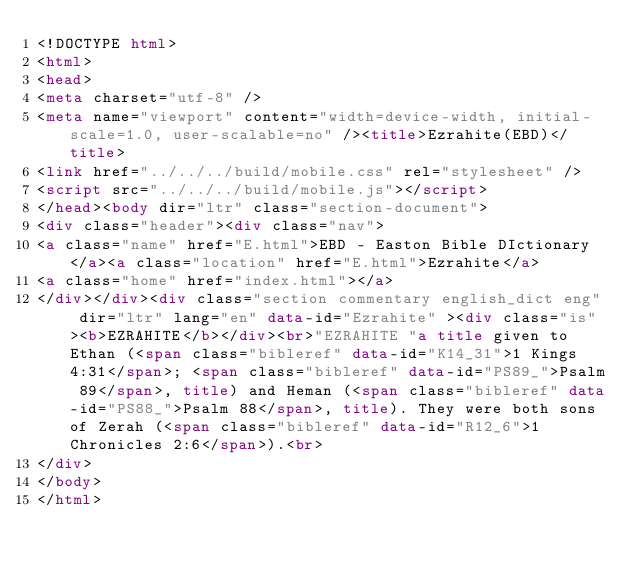<code> <loc_0><loc_0><loc_500><loc_500><_HTML_><!DOCTYPE html>
<html>
<head>
<meta charset="utf-8" />
<meta name="viewport" content="width=device-width, initial-scale=1.0, user-scalable=no" /><title>Ezrahite(EBD)</title>
<link href="../../../build/mobile.css" rel="stylesheet" />
<script src="../../../build/mobile.js"></script>
</head><body dir="ltr" class="section-document">
<div class="header"><div class="nav">
<a class="name" href="E.html">EBD - Easton Bible DIctionary</a><a class="location" href="E.html">Ezrahite</a>
<a class="home" href="index.html"></a>
</div></div><div class="section commentary english_dict eng" dir="ltr" lang="en" data-id="Ezrahite" ><div class="is"><b>EZRAHITE</b></div><br>"EZRAHITE "a title given to Ethan (<span class="bibleref" data-id="K14_31">1 Kings 4:31</span>; <span class="bibleref" data-id="PS89_">Psalm 89</span>, title) and Heman (<span class="bibleref" data-id="PS88_">Psalm 88</span>, title). They were both sons of Zerah (<span class="bibleref" data-id="R12_6">1 Chronicles 2:6</span>).<br>
</div>
</body>
</html>
</code> 